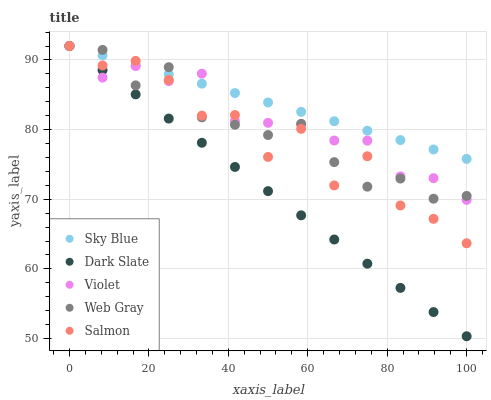Does Dark Slate have the minimum area under the curve?
Answer yes or no. Yes. Does Sky Blue have the maximum area under the curve?
Answer yes or no. Yes. Does Violet have the minimum area under the curve?
Answer yes or no. No. Does Violet have the maximum area under the curve?
Answer yes or no. No. Is Dark Slate the smoothest?
Answer yes or no. Yes. Is Salmon the roughest?
Answer yes or no. Yes. Is Violet the smoothest?
Answer yes or no. No. Is Violet the roughest?
Answer yes or no. No. Does Dark Slate have the lowest value?
Answer yes or no. Yes. Does Violet have the lowest value?
Answer yes or no. No. Does Dark Slate have the highest value?
Answer yes or no. Yes. Does Sky Blue intersect Salmon?
Answer yes or no. Yes. Is Sky Blue less than Salmon?
Answer yes or no. No. Is Sky Blue greater than Salmon?
Answer yes or no. No. 